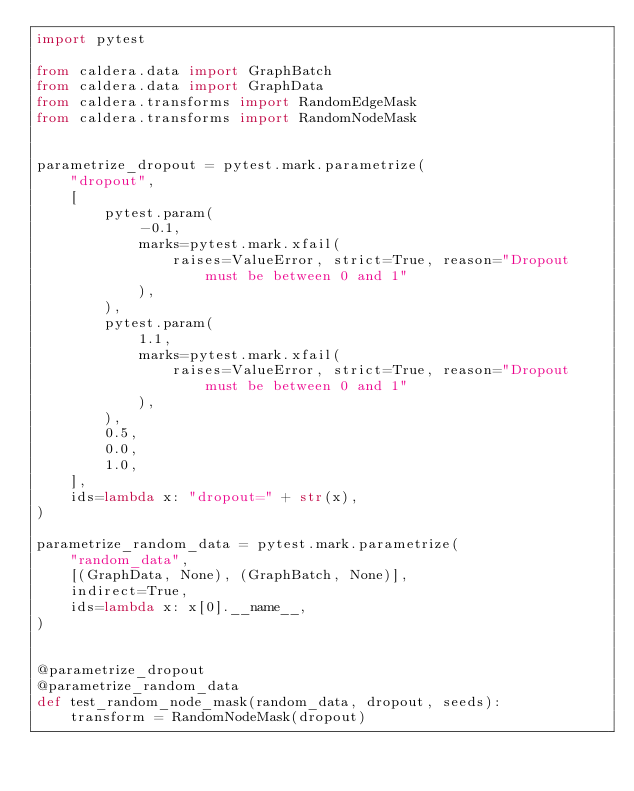<code> <loc_0><loc_0><loc_500><loc_500><_Python_>import pytest

from caldera.data import GraphBatch
from caldera.data import GraphData
from caldera.transforms import RandomEdgeMask
from caldera.transforms import RandomNodeMask


parametrize_dropout = pytest.mark.parametrize(
    "dropout",
    [
        pytest.param(
            -0.1,
            marks=pytest.mark.xfail(
                raises=ValueError, strict=True, reason="Dropout must be between 0 and 1"
            ),
        ),
        pytest.param(
            1.1,
            marks=pytest.mark.xfail(
                raises=ValueError, strict=True, reason="Dropout must be between 0 and 1"
            ),
        ),
        0.5,
        0.0,
        1.0,
    ],
    ids=lambda x: "dropout=" + str(x),
)

parametrize_random_data = pytest.mark.parametrize(
    "random_data",
    [(GraphData, None), (GraphBatch, None)],
    indirect=True,
    ids=lambda x: x[0].__name__,
)


@parametrize_dropout
@parametrize_random_data
def test_random_node_mask(random_data, dropout, seeds):
    transform = RandomNodeMask(dropout)</code> 